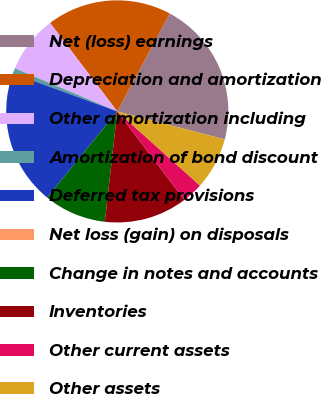Convert chart. <chart><loc_0><loc_0><loc_500><loc_500><pie_chart><fcel>Net (loss) earnings<fcel>Depreciation and amortization<fcel>Other amortization including<fcel>Amortization of bond discount<fcel>Deferred tax provisions<fcel>Net loss (gain) on disposals<fcel>Change in notes and accounts<fcel>Inventories<fcel>Other current assets<fcel>Other assets<nl><fcel>21.21%<fcel>18.18%<fcel>8.33%<fcel>0.76%<fcel>19.69%<fcel>0.0%<fcel>9.09%<fcel>12.12%<fcel>3.03%<fcel>7.58%<nl></chart> 